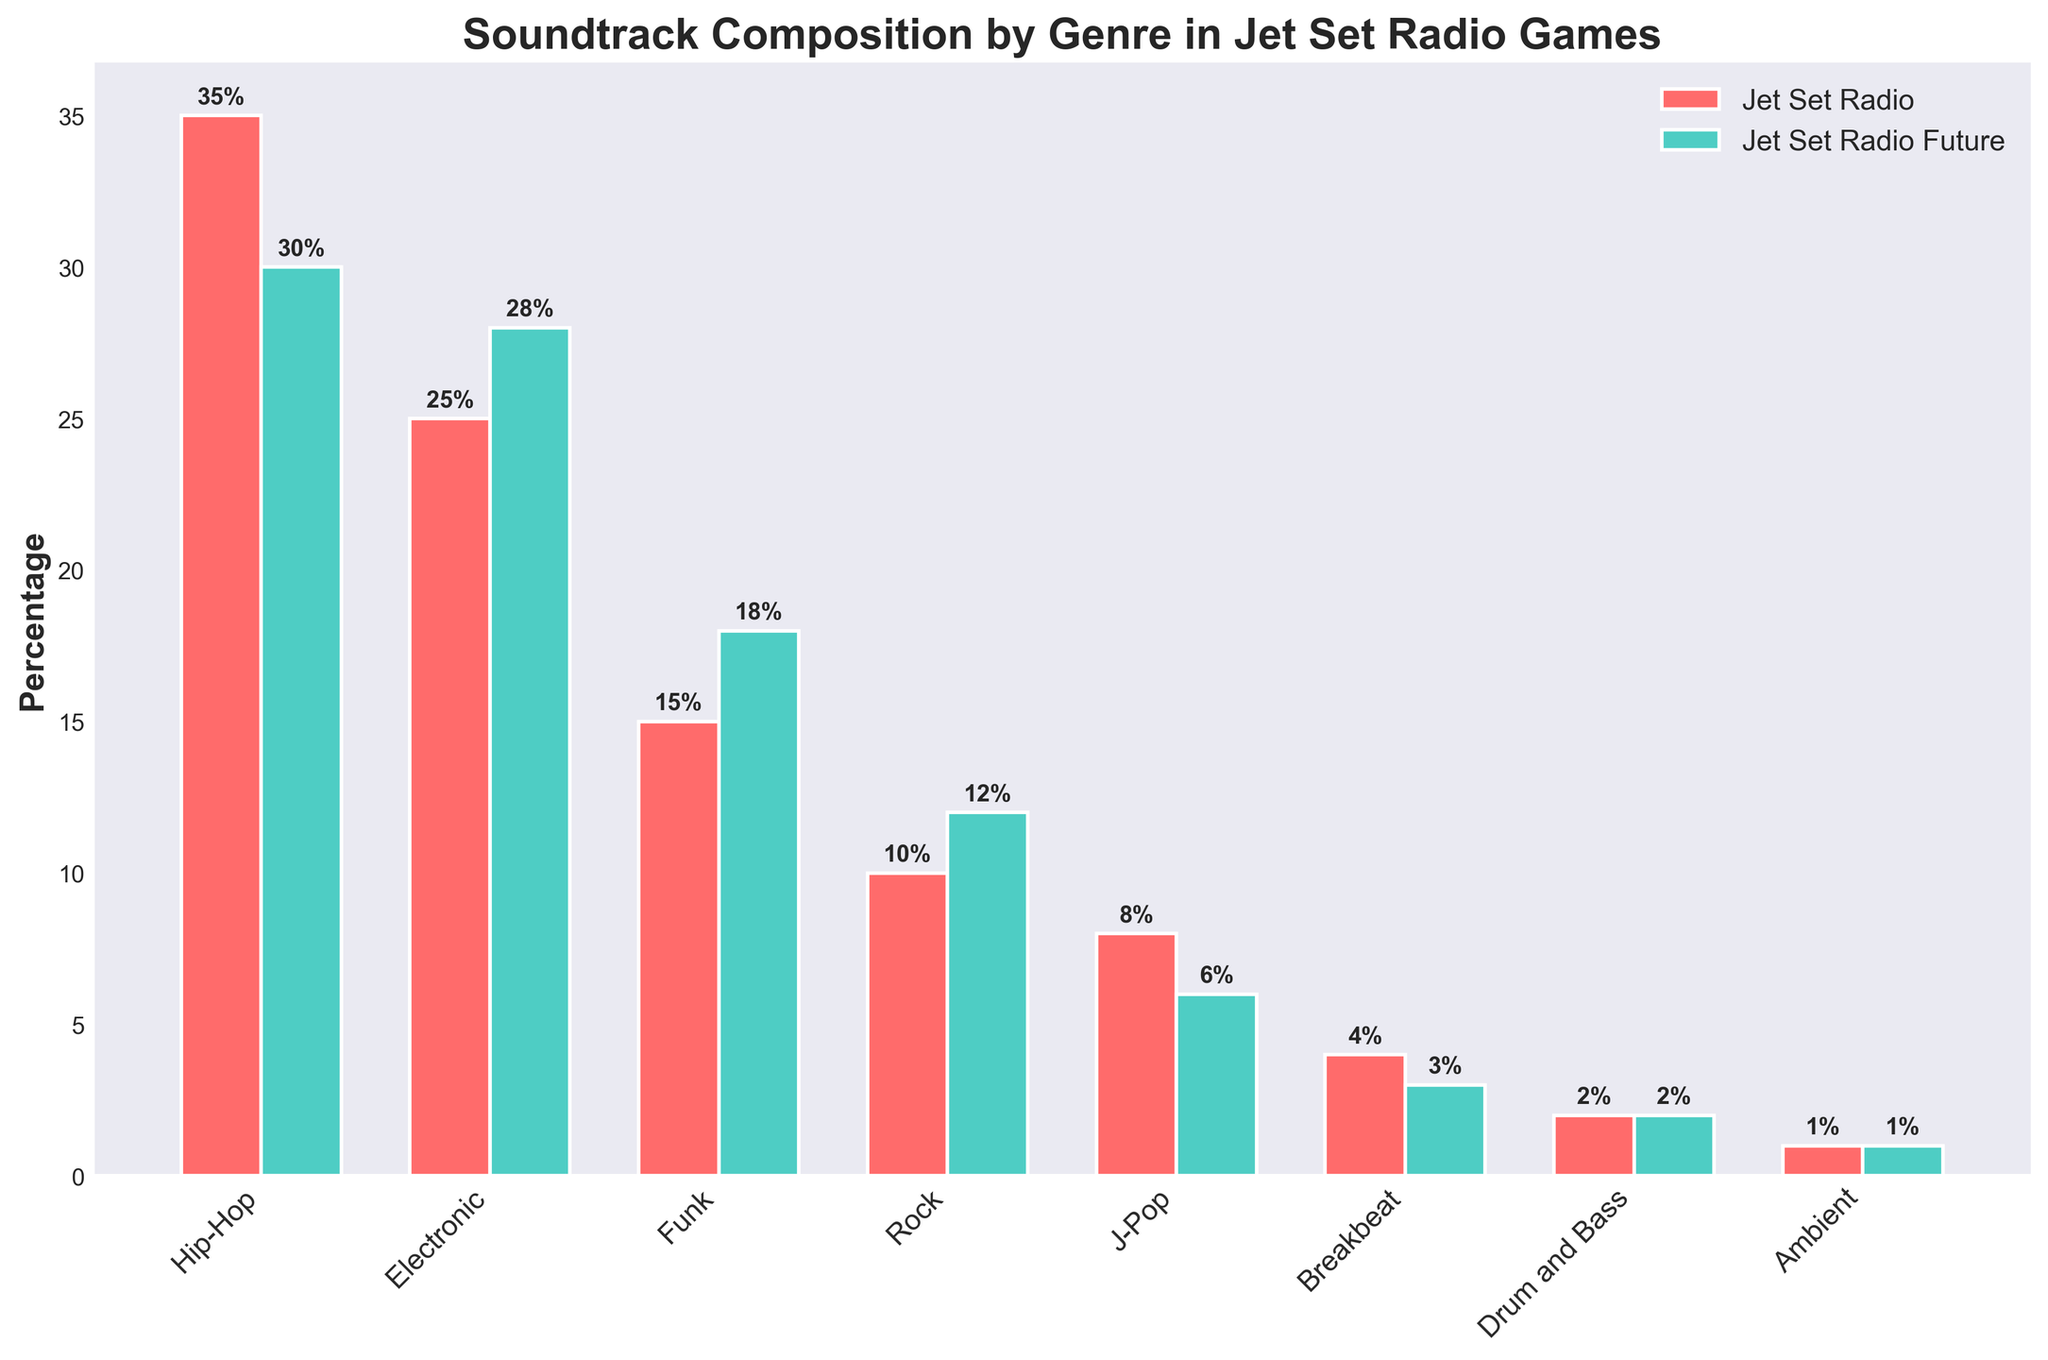what are the two most represented genres in both games combined? Add the percentages for each genre in both games: Hip-Hop (35 + 30 = 65), Electronic (25 + 28 = 53), Funk (15 + 18 = 33), Rock (10 + 12 = 22), J-Pop (8 + 6 = 14), Breakbeat (4 + 3 = 7), Drum and Bass (2 + 2 = 4), Ambient (1 + 1 = 2). Hip-Hop and Electronic have the highest combined values.
Answer: Hip-Hop and Electronic Which game has a higher percentage of Funk tracks? Compare the height of the Funk bars. In Jet Set Radio, Funk is at 15%, and in Jet Set Radio Future, it is at 18%. 18% is greater than 15%.
Answer: Jet Set Radio Future What is the total percentage of genres that are less than or equal to 5% in Jet Set Radio Future? Identify the genres with 5% or less: J-Pop (6%), Breakbeat (3%), Drum and Bass (2%), and Ambient (1%). Sum them: 6 + 3 + 2 + 1 = 12%.
Answer: 12% Which genre has more representation in Jet Set Radio than in Jet Set Radio Future and by how much? Compare the values directly: Hip-Hop (35% - 30% = 5%), Electronic (25% - 28% = -3%), Funk (15% - 18% = -3%), Rock (10% - 12% = -2%), J-Pop (8% - 6% = 2%), Breakbeat (4% - 3% = 1%), Drum and Bass (2% - 2% = 0%), Ambient (1% - 1% = 0%). Hip-Hop has 5% more representation in Jet Set Radio.
Answer: Hip-Hop, 5% What is the average percentage of Rock tracks across both games? Calculate the mean of the Rock percentages: (10 + 12) / 2 = 22 / 2 = 11%.
Answer: 11% Which genre had the smallest change in percentage between the two games? Find the absolute differences between the genres: Hip-Hop (5%), Electronic (3%), Funk (3%), Rock (2%), J-Pop (2%), Breakbeat (1%), Drum and Bass (0%), Ambient (0%). Drum and Bass and Ambient had the smallest change of 0%.
Answer: Drum and Bass and Ambient Among the genres, which one has the lowest combined percentage across both games? Add the percentages for each genre in both games: Hip-Hop (65%), Electronic (53%), Funk (33%), Rock (22%), J-Pop (14%), Breakbeat (7%), Drum and Bass (4%), Ambient (2%). Ambient has the lowest combined percentage.
Answer: Ambient What is the combined percentage of Hip-Hop and Electronic tracks in Jet Set Radio? Sum the percentages for Hip-Hop and Electronic in Jet Set Radio: 35 + 25 = 60%.
Answer: 60% How many genres in Jet Set Radio have a higher percentage than Breakbeat in Jet Set Radio Future? Identify the percentage of Breakbeat in Jet Set Radio Future (3%) and count the genres in Jet Set Radio with more than 3%: Hip-Hop (35%), Electronic (25%), Funk (15%), Rock (10%), J-Pop (8%). There are 5 such genres.
Answer: 5 genres 